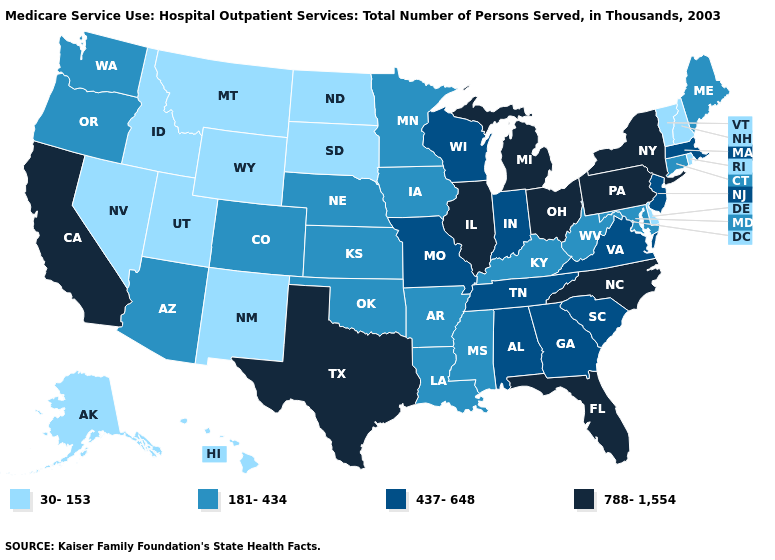What is the value of Idaho?
Quick response, please. 30-153. Name the states that have a value in the range 181-434?
Give a very brief answer. Arizona, Arkansas, Colorado, Connecticut, Iowa, Kansas, Kentucky, Louisiana, Maine, Maryland, Minnesota, Mississippi, Nebraska, Oklahoma, Oregon, Washington, West Virginia. What is the lowest value in states that border Florida?
Write a very short answer. 437-648. Among the states that border Oregon , does California have the lowest value?
Give a very brief answer. No. What is the highest value in states that border Idaho?
Quick response, please. 181-434. What is the value of Texas?
Keep it brief. 788-1,554. What is the value of Virginia?
Short answer required. 437-648. What is the value of New Jersey?
Short answer required. 437-648. Name the states that have a value in the range 437-648?
Short answer required. Alabama, Georgia, Indiana, Massachusetts, Missouri, New Jersey, South Carolina, Tennessee, Virginia, Wisconsin. Does Nevada have the same value as Tennessee?
Concise answer only. No. Which states have the lowest value in the USA?
Answer briefly. Alaska, Delaware, Hawaii, Idaho, Montana, Nevada, New Hampshire, New Mexico, North Dakota, Rhode Island, South Dakota, Utah, Vermont, Wyoming. Which states have the highest value in the USA?
Give a very brief answer. California, Florida, Illinois, Michigan, New York, North Carolina, Ohio, Pennsylvania, Texas. What is the highest value in the USA?
Write a very short answer. 788-1,554. What is the lowest value in states that border Texas?
Quick response, please. 30-153. What is the value of Colorado?
Quick response, please. 181-434. 